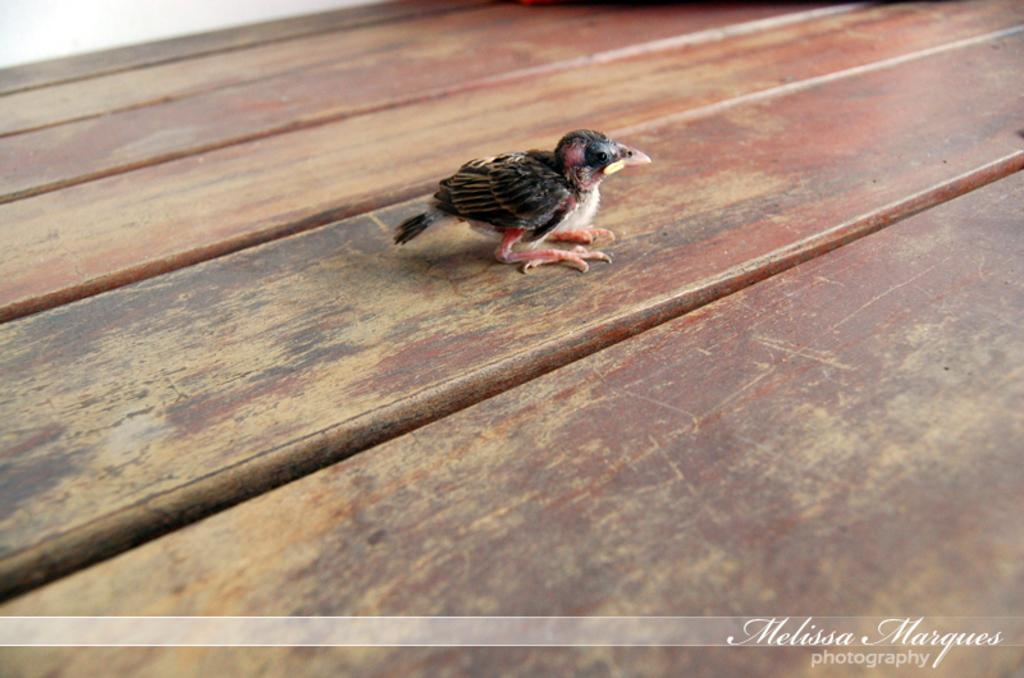What type of animal is in the image? There is a small bird in the image. What color is the bird? The bird is black in color. Where is the bird located in the image? The bird is on a wooden surface. What is the color of the wooden surface? The wooden surface is brown in color. What additional detail can be observed on the right side of the image? There is a white color water mark on the right side of the image. What type of stamp can be seen on the bird's wing in the image? There is no stamp present on the bird's wing in the image. How does the bird maintain its balance while standing on the wooden surface? The image does not show the bird standing or maintaining its balance, so it cannot be determined from the image. 